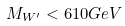Convert formula to latex. <formula><loc_0><loc_0><loc_500><loc_500>M _ { W ^ { \prime } } < 6 1 0 G e V</formula> 